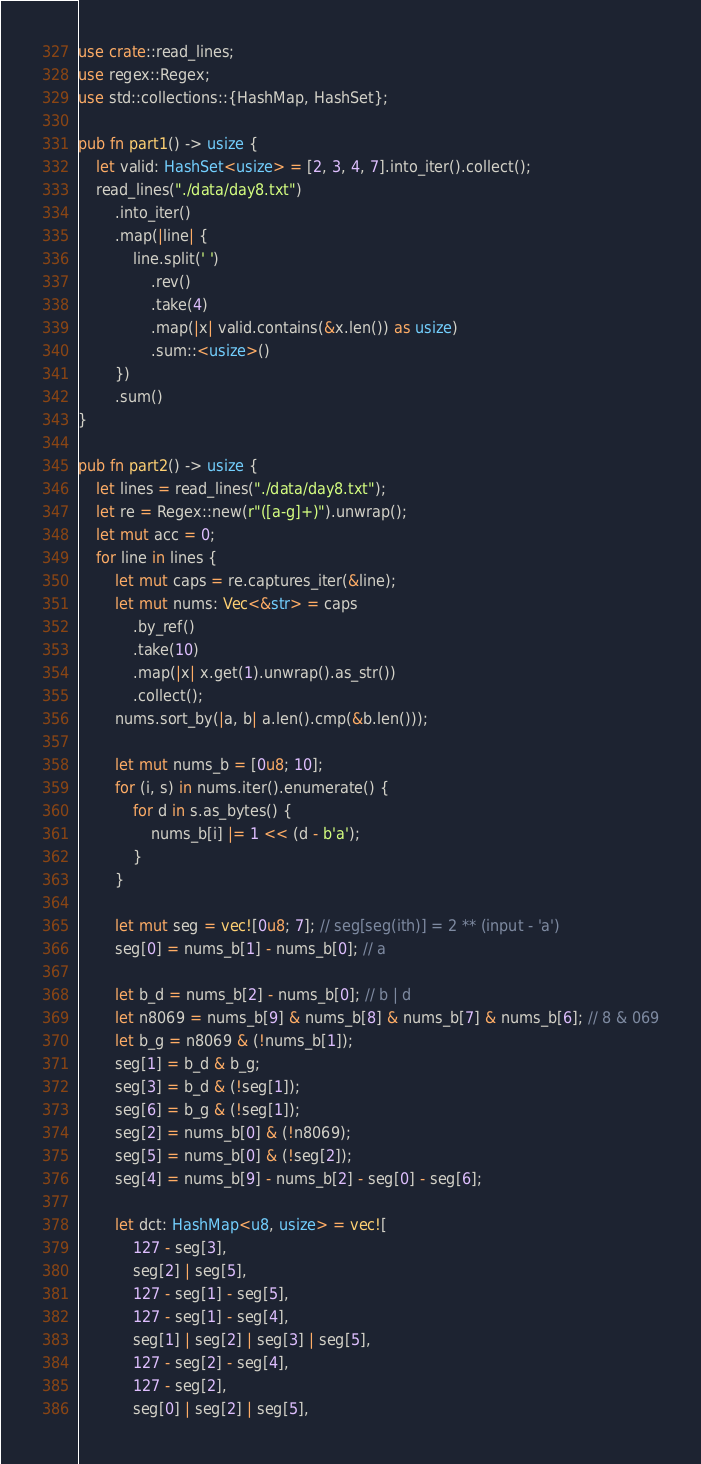Convert code to text. <code><loc_0><loc_0><loc_500><loc_500><_Rust_>use crate::read_lines;
use regex::Regex;
use std::collections::{HashMap, HashSet};

pub fn part1() -> usize {
    let valid: HashSet<usize> = [2, 3, 4, 7].into_iter().collect();
    read_lines("./data/day8.txt")
        .into_iter()
        .map(|line| {
            line.split(' ')
                .rev()
                .take(4)
                .map(|x| valid.contains(&x.len()) as usize)
                .sum::<usize>()
        })
        .sum()
}

pub fn part2() -> usize {
    let lines = read_lines("./data/day8.txt");
    let re = Regex::new(r"([a-g]+)").unwrap();
    let mut acc = 0;
    for line in lines {
        let mut caps = re.captures_iter(&line);
        let mut nums: Vec<&str> = caps
            .by_ref()
            .take(10)
            .map(|x| x.get(1).unwrap().as_str())
            .collect();
        nums.sort_by(|a, b| a.len().cmp(&b.len()));

        let mut nums_b = [0u8; 10];
        for (i, s) in nums.iter().enumerate() {
            for d in s.as_bytes() {
                nums_b[i] |= 1 << (d - b'a');
            }
        }

        let mut seg = vec![0u8; 7]; // seg[seg(ith)] = 2 ** (input - 'a')
        seg[0] = nums_b[1] - nums_b[0]; // a

        let b_d = nums_b[2] - nums_b[0]; // b | d
        let n8069 = nums_b[9] & nums_b[8] & nums_b[7] & nums_b[6]; // 8 & 069
        let b_g = n8069 & (!nums_b[1]);
        seg[1] = b_d & b_g;
        seg[3] = b_d & (!seg[1]);
        seg[6] = b_g & (!seg[1]);
        seg[2] = nums_b[0] & (!n8069);
        seg[5] = nums_b[0] & (!seg[2]);
        seg[4] = nums_b[9] - nums_b[2] - seg[0] - seg[6];

        let dct: HashMap<u8, usize> = vec![
            127 - seg[3],
            seg[2] | seg[5],
            127 - seg[1] - seg[5],
            127 - seg[1] - seg[4],
            seg[1] | seg[2] | seg[3] | seg[5],
            127 - seg[2] - seg[4],
            127 - seg[2],
            seg[0] | seg[2] | seg[5],</code> 